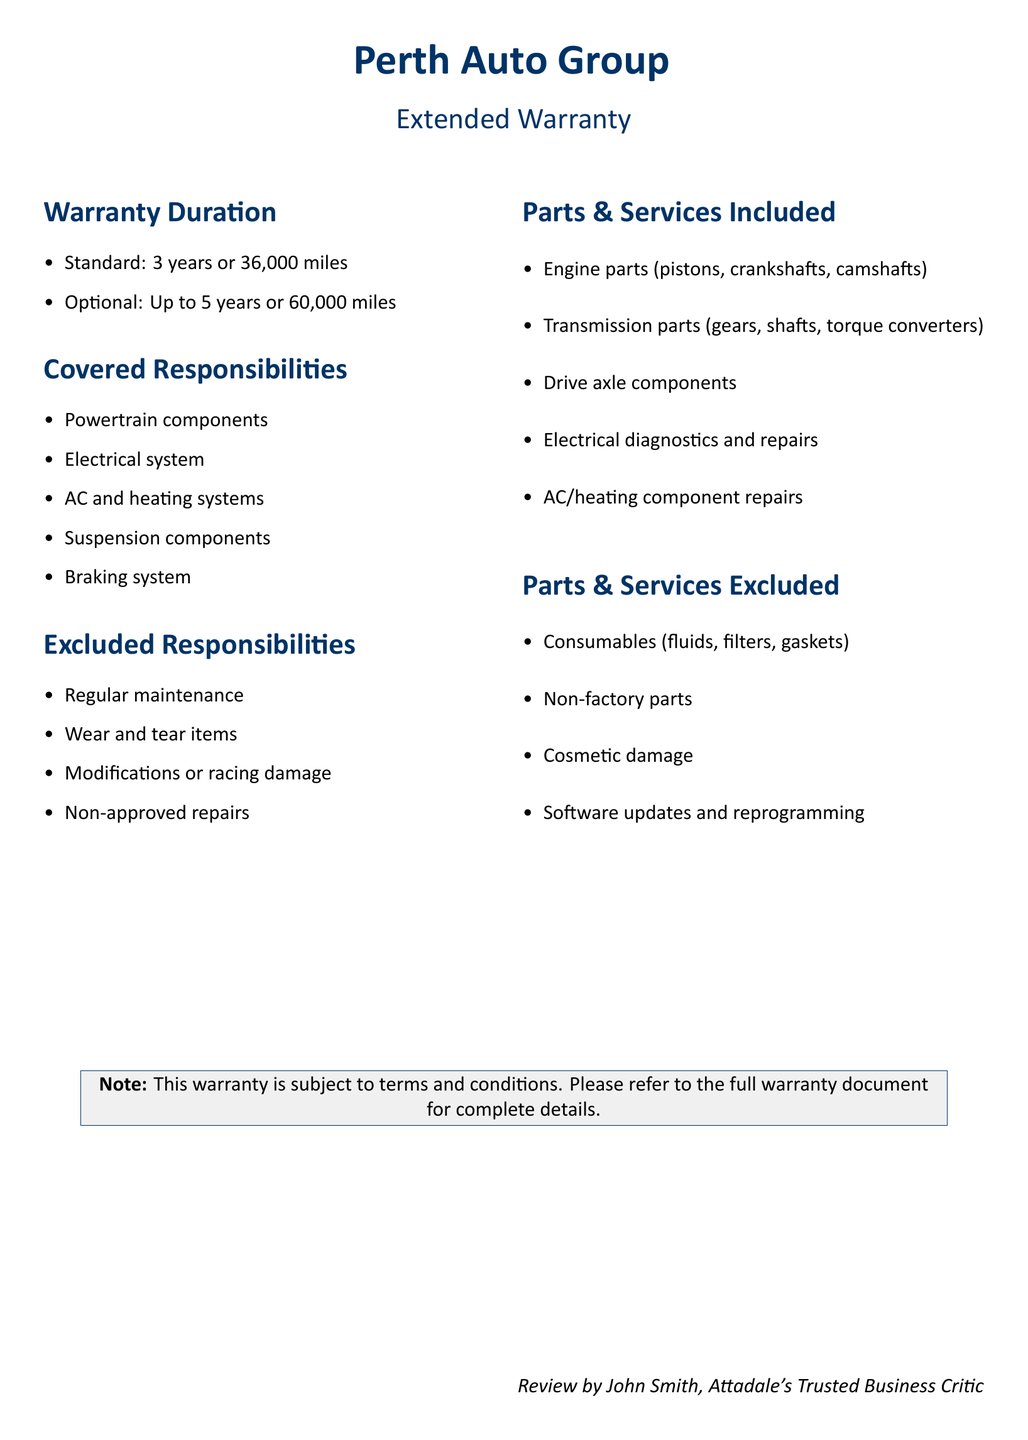What is the standard warranty duration? The standard warranty duration is specified as 3 years or 36,000 miles.
Answer: 3 years or 36,000 miles What is the maximum optional warranty duration? The document states that the optional warranty duration can be up to 5 years or 60,000 miles.
Answer: 5 years or 60,000 miles Which system is included in the covered responsibilities? The document lists several components under covered responsibilities, including the powertrain components, which is one of them.
Answer: Powertrain components What items are explicitly excluded from the warranty? The document outlines excluded responsibilities, among which regular maintenance is highlighted.
Answer: Regular maintenance What type of repairs are not approved under this warranty? The warranty explicitly mentions that non-approved repairs are excluded from coverage.
Answer: Non-approved repairs What is included in the electrical system coverage? The document notes that electrical diagnostics and repairs are included in the warranty.
Answer: Electrical diagnostics and repairs Which part is not included as a consumable? In the parts & services excluded section, it mentions that fluids are consumables and therefore excluded, while engine parts are included.
Answer: Engine parts Is cosmetic damage covered under this warranty? The document clearly lists cosmetic damage in the exclusion section, indicating it is not covered.
Answer: No What should one refer to for complete warranty details? The last section of the document advises to refer to the full warranty document for complete details.
Answer: Full warranty document 